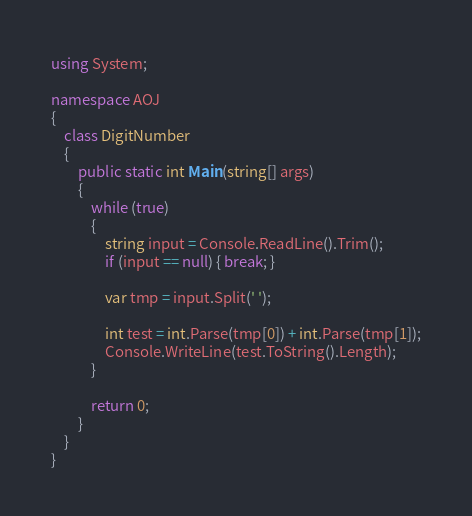Convert code to text. <code><loc_0><loc_0><loc_500><loc_500><_C#_>using System;

namespace AOJ
{
    class DigitNumber
    {
        public static int Main(string[] args)
        {
            while (true)
            {
                string input = Console.ReadLine().Trim();
                if (input == null) { break; }

                var tmp = input.Split(' ');

                int test = int.Parse(tmp[0]) + int.Parse(tmp[1]);
                Console.WriteLine(test.ToString().Length);
            }

            return 0;
        }
    }
}</code> 